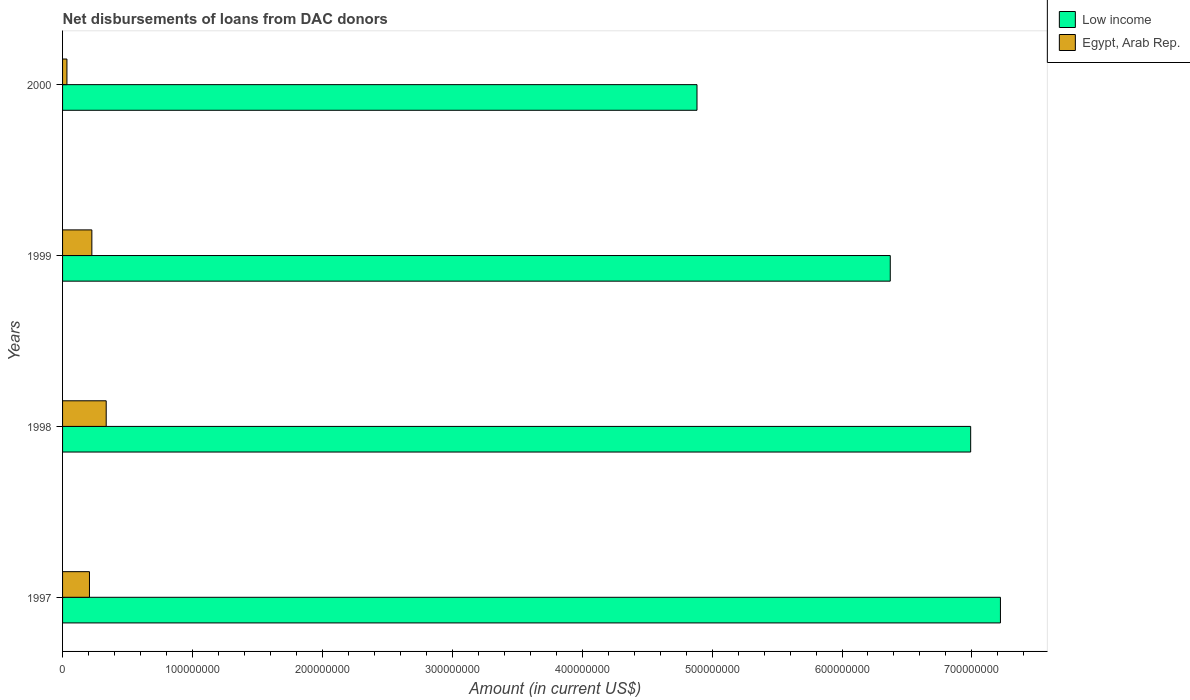How many groups of bars are there?
Keep it short and to the point. 4. Are the number of bars per tick equal to the number of legend labels?
Make the answer very short. Yes. Are the number of bars on each tick of the Y-axis equal?
Give a very brief answer. Yes. In how many cases, is the number of bars for a given year not equal to the number of legend labels?
Your answer should be compact. 0. What is the amount of loans disbursed in Egypt, Arab Rep. in 1998?
Your answer should be very brief. 3.36e+07. Across all years, what is the maximum amount of loans disbursed in Low income?
Your answer should be compact. 7.22e+08. Across all years, what is the minimum amount of loans disbursed in Low income?
Offer a very short reply. 4.88e+08. In which year was the amount of loans disbursed in Low income maximum?
Keep it short and to the point. 1997. What is the total amount of loans disbursed in Egypt, Arab Rep. in the graph?
Give a very brief answer. 8.02e+07. What is the difference between the amount of loans disbursed in Egypt, Arab Rep. in 1997 and that in 2000?
Ensure brevity in your answer.  1.73e+07. What is the difference between the amount of loans disbursed in Egypt, Arab Rep. in 1998 and the amount of loans disbursed in Low income in 1999?
Offer a terse response. -6.04e+08. What is the average amount of loans disbursed in Egypt, Arab Rep. per year?
Keep it short and to the point. 2.01e+07. In the year 1999, what is the difference between the amount of loans disbursed in Low income and amount of loans disbursed in Egypt, Arab Rep.?
Provide a succinct answer. 6.15e+08. In how many years, is the amount of loans disbursed in Low income greater than 560000000 US$?
Your response must be concise. 3. What is the ratio of the amount of loans disbursed in Low income in 1999 to that in 2000?
Ensure brevity in your answer.  1.3. Is the difference between the amount of loans disbursed in Low income in 1997 and 1998 greater than the difference between the amount of loans disbursed in Egypt, Arab Rep. in 1997 and 1998?
Provide a short and direct response. Yes. What is the difference between the highest and the second highest amount of loans disbursed in Egypt, Arab Rep.?
Offer a terse response. 1.10e+07. What is the difference between the highest and the lowest amount of loans disbursed in Low income?
Make the answer very short. 2.34e+08. Is the sum of the amount of loans disbursed in Egypt, Arab Rep. in 1998 and 1999 greater than the maximum amount of loans disbursed in Low income across all years?
Offer a terse response. No. What does the 1st bar from the top in 1997 represents?
Give a very brief answer. Egypt, Arab Rep. What does the 2nd bar from the bottom in 2000 represents?
Your answer should be very brief. Egypt, Arab Rep. How many years are there in the graph?
Ensure brevity in your answer.  4. What is the difference between two consecutive major ticks on the X-axis?
Keep it short and to the point. 1.00e+08. Are the values on the major ticks of X-axis written in scientific E-notation?
Your answer should be compact. No. Does the graph contain grids?
Make the answer very short. No. Where does the legend appear in the graph?
Your answer should be compact. Top right. What is the title of the graph?
Keep it short and to the point. Net disbursements of loans from DAC donors. What is the Amount (in current US$) in Low income in 1997?
Give a very brief answer. 7.22e+08. What is the Amount (in current US$) of Egypt, Arab Rep. in 1997?
Ensure brevity in your answer.  2.07e+07. What is the Amount (in current US$) in Low income in 1998?
Provide a succinct answer. 6.99e+08. What is the Amount (in current US$) of Egypt, Arab Rep. in 1998?
Provide a short and direct response. 3.36e+07. What is the Amount (in current US$) of Low income in 1999?
Your answer should be very brief. 6.37e+08. What is the Amount (in current US$) in Egypt, Arab Rep. in 1999?
Your answer should be compact. 2.25e+07. What is the Amount (in current US$) of Low income in 2000?
Ensure brevity in your answer.  4.88e+08. What is the Amount (in current US$) in Egypt, Arab Rep. in 2000?
Give a very brief answer. 3.37e+06. Across all years, what is the maximum Amount (in current US$) of Low income?
Your response must be concise. 7.22e+08. Across all years, what is the maximum Amount (in current US$) in Egypt, Arab Rep.?
Give a very brief answer. 3.36e+07. Across all years, what is the minimum Amount (in current US$) of Low income?
Ensure brevity in your answer.  4.88e+08. Across all years, what is the minimum Amount (in current US$) of Egypt, Arab Rep.?
Provide a succinct answer. 3.37e+06. What is the total Amount (in current US$) in Low income in the graph?
Give a very brief answer. 2.55e+09. What is the total Amount (in current US$) in Egypt, Arab Rep. in the graph?
Provide a succinct answer. 8.02e+07. What is the difference between the Amount (in current US$) of Low income in 1997 and that in 1998?
Offer a terse response. 2.29e+07. What is the difference between the Amount (in current US$) of Egypt, Arab Rep. in 1997 and that in 1998?
Ensure brevity in your answer.  -1.29e+07. What is the difference between the Amount (in current US$) in Low income in 1997 and that in 1999?
Provide a short and direct response. 8.48e+07. What is the difference between the Amount (in current US$) in Egypt, Arab Rep. in 1997 and that in 1999?
Your answer should be compact. -1.84e+06. What is the difference between the Amount (in current US$) in Low income in 1997 and that in 2000?
Ensure brevity in your answer.  2.34e+08. What is the difference between the Amount (in current US$) of Egypt, Arab Rep. in 1997 and that in 2000?
Keep it short and to the point. 1.73e+07. What is the difference between the Amount (in current US$) in Low income in 1998 and that in 1999?
Your answer should be very brief. 6.19e+07. What is the difference between the Amount (in current US$) of Egypt, Arab Rep. in 1998 and that in 1999?
Your response must be concise. 1.10e+07. What is the difference between the Amount (in current US$) of Low income in 1998 and that in 2000?
Provide a succinct answer. 2.11e+08. What is the difference between the Amount (in current US$) in Egypt, Arab Rep. in 1998 and that in 2000?
Your answer should be very brief. 3.02e+07. What is the difference between the Amount (in current US$) of Low income in 1999 and that in 2000?
Ensure brevity in your answer.  1.49e+08. What is the difference between the Amount (in current US$) in Egypt, Arab Rep. in 1999 and that in 2000?
Your response must be concise. 1.92e+07. What is the difference between the Amount (in current US$) in Low income in 1997 and the Amount (in current US$) in Egypt, Arab Rep. in 1998?
Ensure brevity in your answer.  6.88e+08. What is the difference between the Amount (in current US$) in Low income in 1997 and the Amount (in current US$) in Egypt, Arab Rep. in 1999?
Make the answer very short. 6.99e+08. What is the difference between the Amount (in current US$) of Low income in 1997 and the Amount (in current US$) of Egypt, Arab Rep. in 2000?
Your response must be concise. 7.19e+08. What is the difference between the Amount (in current US$) in Low income in 1998 and the Amount (in current US$) in Egypt, Arab Rep. in 1999?
Give a very brief answer. 6.77e+08. What is the difference between the Amount (in current US$) of Low income in 1998 and the Amount (in current US$) of Egypt, Arab Rep. in 2000?
Keep it short and to the point. 6.96e+08. What is the difference between the Amount (in current US$) in Low income in 1999 and the Amount (in current US$) in Egypt, Arab Rep. in 2000?
Give a very brief answer. 6.34e+08. What is the average Amount (in current US$) in Low income per year?
Ensure brevity in your answer.  6.37e+08. What is the average Amount (in current US$) of Egypt, Arab Rep. per year?
Ensure brevity in your answer.  2.01e+07. In the year 1997, what is the difference between the Amount (in current US$) in Low income and Amount (in current US$) in Egypt, Arab Rep.?
Give a very brief answer. 7.01e+08. In the year 1998, what is the difference between the Amount (in current US$) of Low income and Amount (in current US$) of Egypt, Arab Rep.?
Provide a short and direct response. 6.65e+08. In the year 1999, what is the difference between the Amount (in current US$) of Low income and Amount (in current US$) of Egypt, Arab Rep.?
Provide a succinct answer. 6.15e+08. In the year 2000, what is the difference between the Amount (in current US$) of Low income and Amount (in current US$) of Egypt, Arab Rep.?
Make the answer very short. 4.85e+08. What is the ratio of the Amount (in current US$) of Low income in 1997 to that in 1998?
Your answer should be compact. 1.03. What is the ratio of the Amount (in current US$) in Egypt, Arab Rep. in 1997 to that in 1998?
Keep it short and to the point. 0.62. What is the ratio of the Amount (in current US$) of Low income in 1997 to that in 1999?
Offer a terse response. 1.13. What is the ratio of the Amount (in current US$) in Egypt, Arab Rep. in 1997 to that in 1999?
Offer a terse response. 0.92. What is the ratio of the Amount (in current US$) of Low income in 1997 to that in 2000?
Provide a short and direct response. 1.48. What is the ratio of the Amount (in current US$) of Egypt, Arab Rep. in 1997 to that in 2000?
Keep it short and to the point. 6.15. What is the ratio of the Amount (in current US$) in Low income in 1998 to that in 1999?
Provide a short and direct response. 1.1. What is the ratio of the Amount (in current US$) in Egypt, Arab Rep. in 1998 to that in 1999?
Your answer should be very brief. 1.49. What is the ratio of the Amount (in current US$) of Low income in 1998 to that in 2000?
Provide a succinct answer. 1.43. What is the ratio of the Amount (in current US$) in Egypt, Arab Rep. in 1998 to that in 2000?
Offer a terse response. 9.97. What is the ratio of the Amount (in current US$) of Low income in 1999 to that in 2000?
Offer a very short reply. 1.3. What is the ratio of the Amount (in current US$) in Egypt, Arab Rep. in 1999 to that in 2000?
Give a very brief answer. 6.69. What is the difference between the highest and the second highest Amount (in current US$) of Low income?
Make the answer very short. 2.29e+07. What is the difference between the highest and the second highest Amount (in current US$) of Egypt, Arab Rep.?
Your answer should be compact. 1.10e+07. What is the difference between the highest and the lowest Amount (in current US$) of Low income?
Give a very brief answer. 2.34e+08. What is the difference between the highest and the lowest Amount (in current US$) in Egypt, Arab Rep.?
Provide a short and direct response. 3.02e+07. 